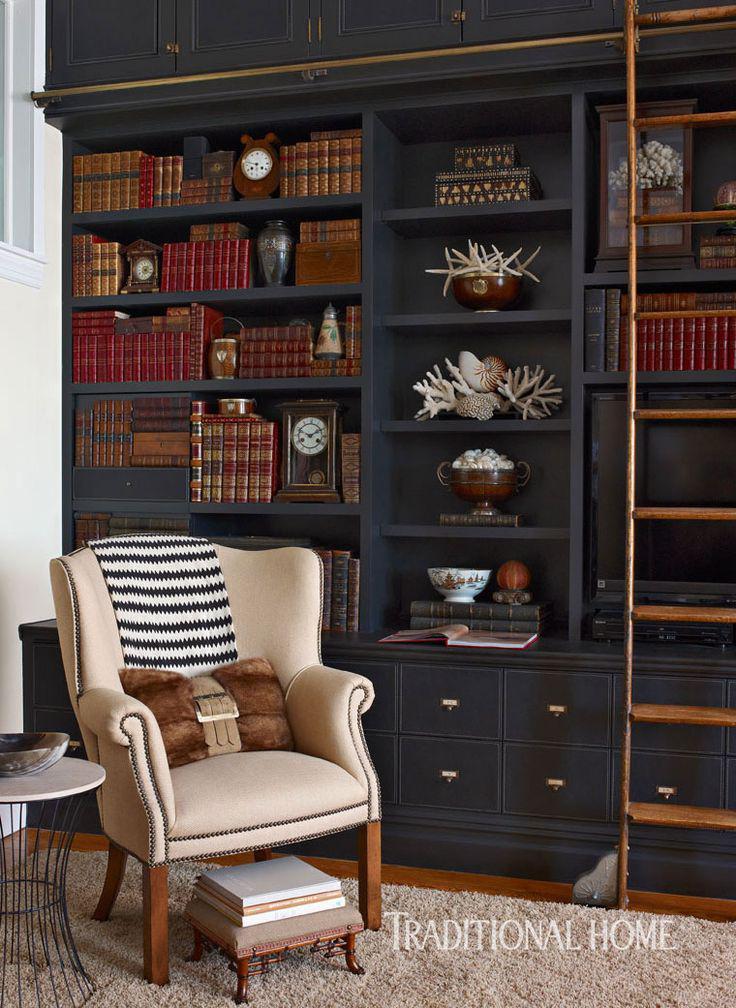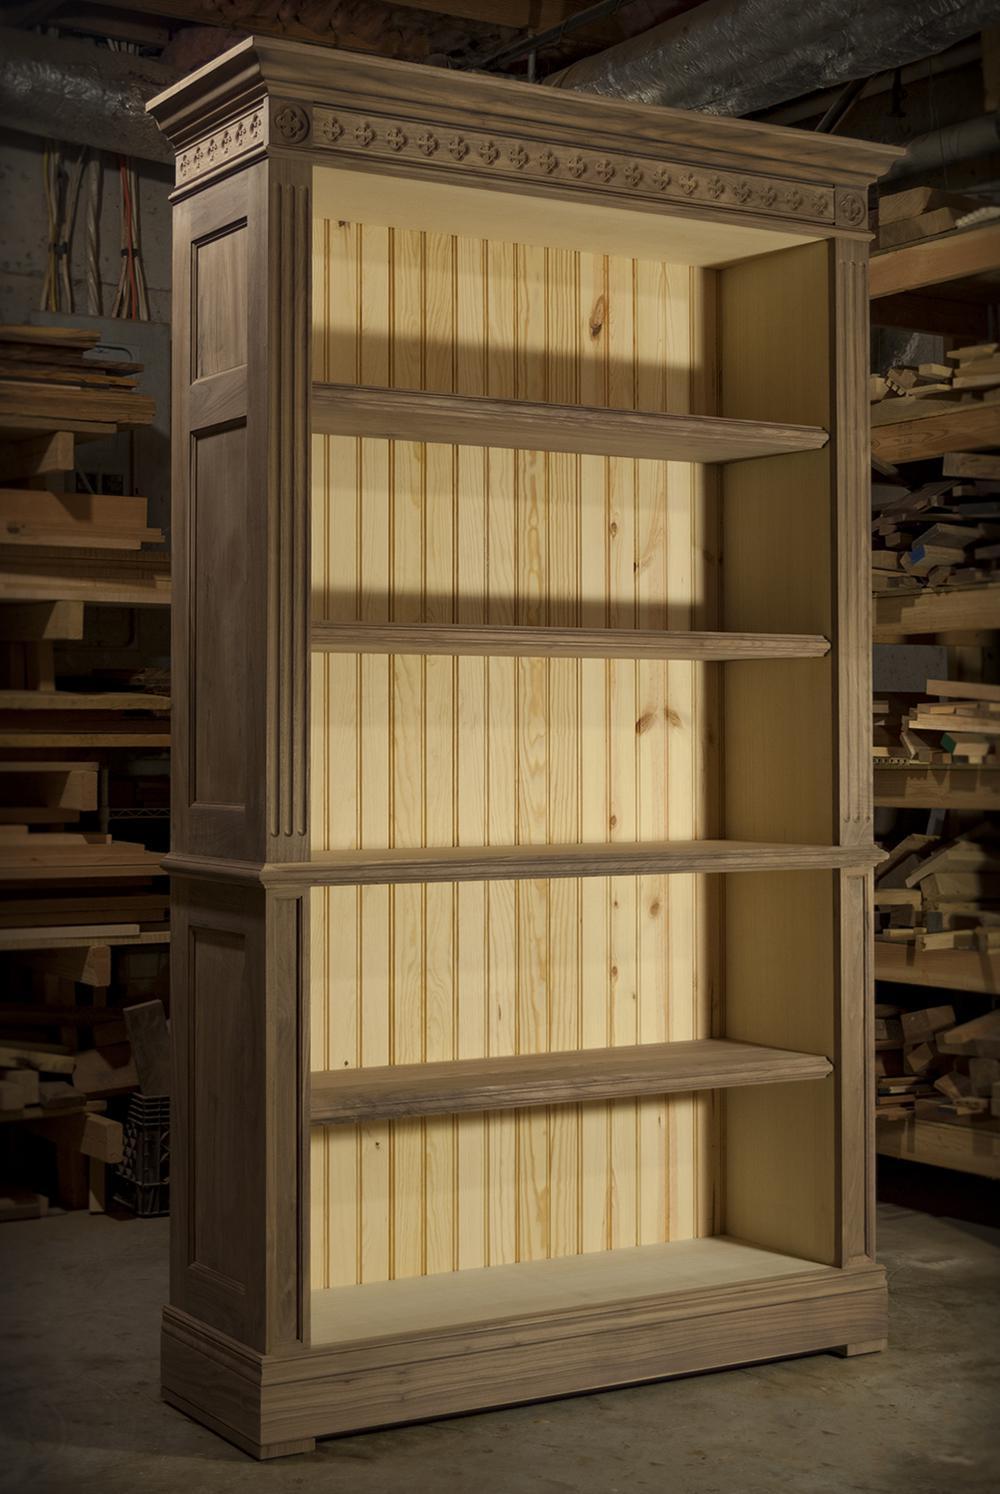The first image is the image on the left, the second image is the image on the right. For the images displayed, is the sentence "There is an empty case of bookshelf." factually correct? Answer yes or no. Yes. 